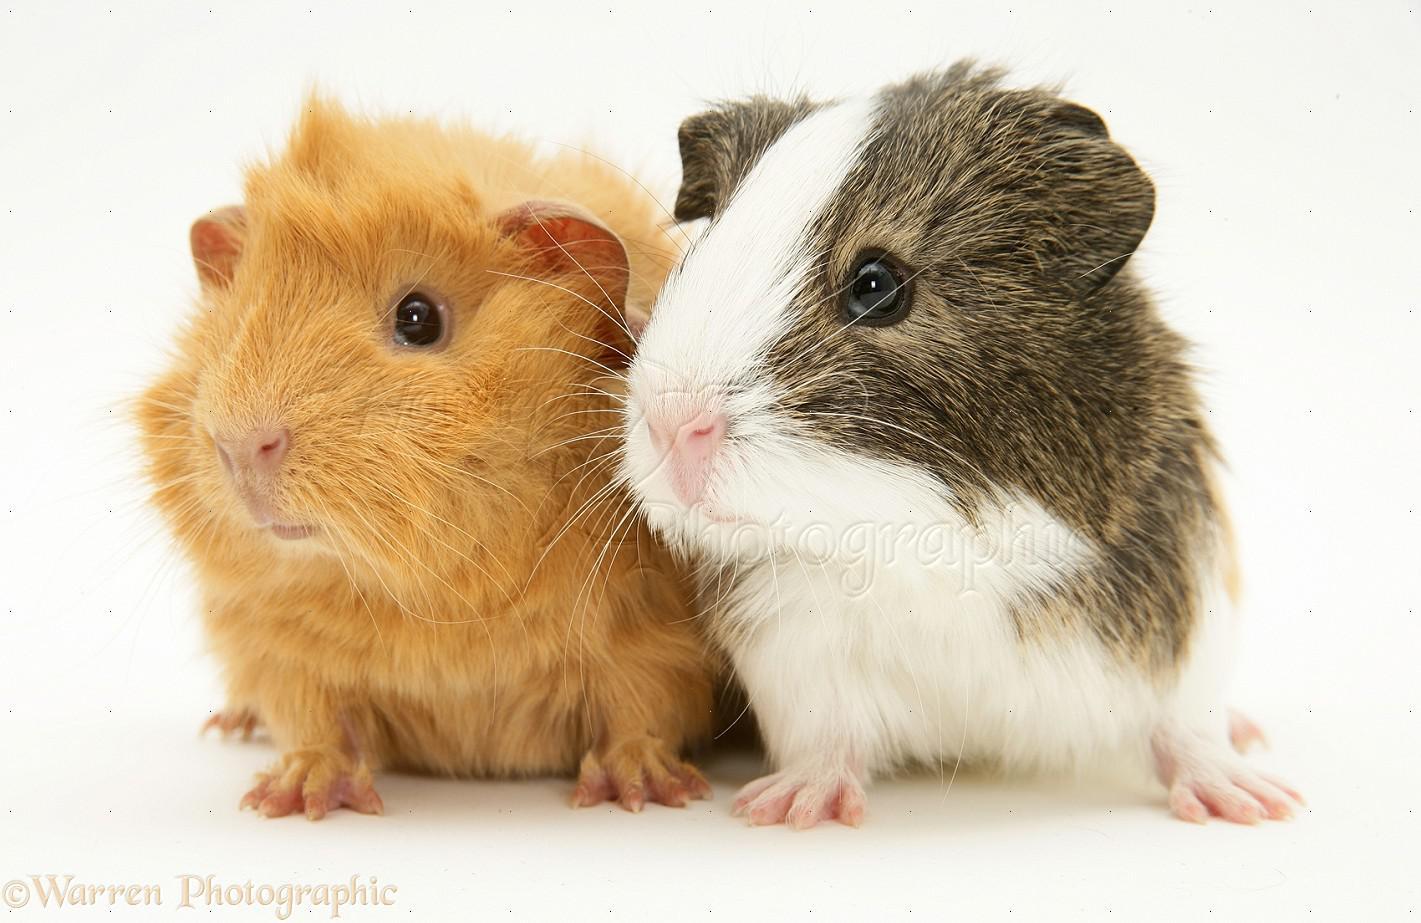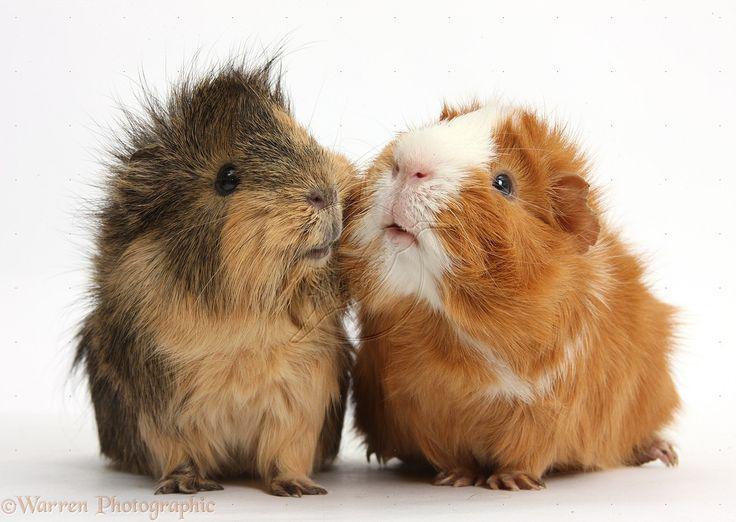The first image is the image on the left, the second image is the image on the right. Considering the images on both sides, is "The right image has three guinea pigs." valid? Answer yes or no. No. The first image is the image on the left, the second image is the image on the right. Assess this claim about the two images: "All of the animals are a type of guinea pig and none of them are sitting on top of each other.". Correct or not? Answer yes or no. Yes. 